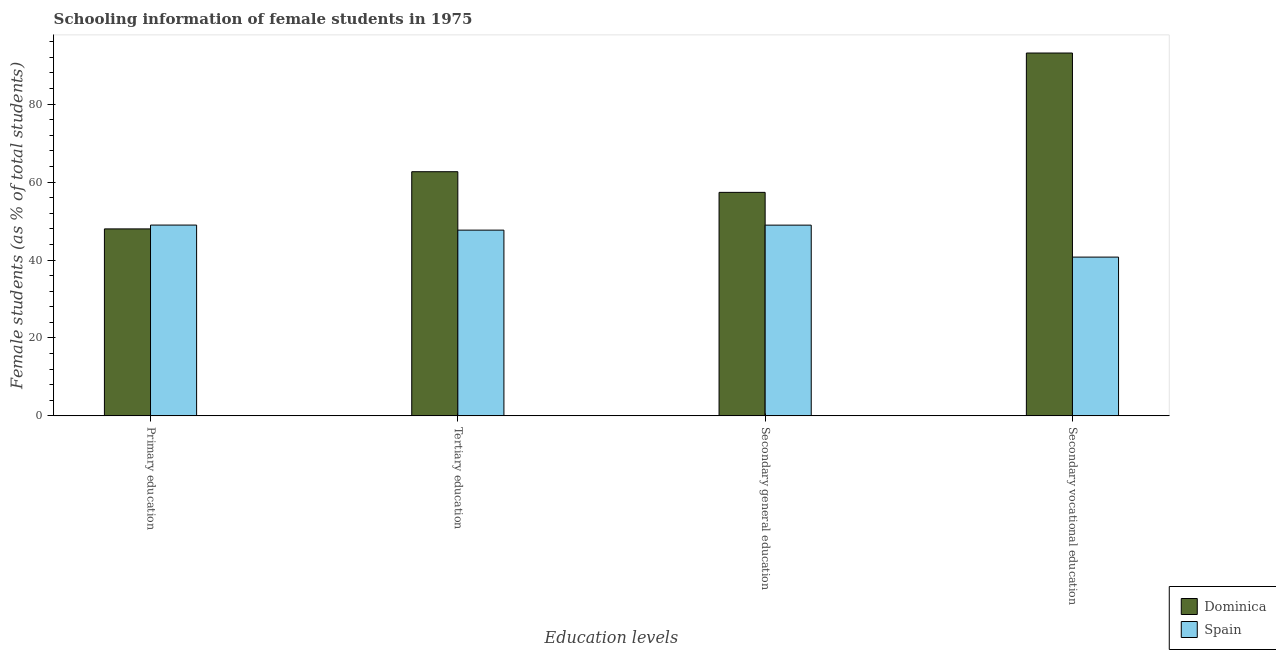Are the number of bars per tick equal to the number of legend labels?
Your answer should be compact. Yes. Are the number of bars on each tick of the X-axis equal?
Offer a terse response. Yes. What is the percentage of female students in primary education in Dominica?
Provide a short and direct response. 47.98. Across all countries, what is the maximum percentage of female students in secondary education?
Your response must be concise. 57.36. Across all countries, what is the minimum percentage of female students in primary education?
Keep it short and to the point. 47.98. In which country was the percentage of female students in tertiary education maximum?
Offer a terse response. Dominica. In which country was the percentage of female students in tertiary education minimum?
Provide a short and direct response. Spain. What is the total percentage of female students in primary education in the graph?
Offer a terse response. 96.95. What is the difference between the percentage of female students in tertiary education in Spain and that in Dominica?
Give a very brief answer. -14.99. What is the difference between the percentage of female students in secondary education in Dominica and the percentage of female students in tertiary education in Spain?
Your answer should be very brief. 9.69. What is the average percentage of female students in tertiary education per country?
Ensure brevity in your answer.  55.16. What is the difference between the percentage of female students in secondary vocational education and percentage of female students in secondary education in Dominica?
Provide a succinct answer. 35.76. In how many countries, is the percentage of female students in secondary vocational education greater than 52 %?
Your answer should be very brief. 1. What is the ratio of the percentage of female students in secondary education in Spain to that in Dominica?
Keep it short and to the point. 0.85. Is the percentage of female students in secondary education in Dominica less than that in Spain?
Your answer should be very brief. No. What is the difference between the highest and the second highest percentage of female students in primary education?
Provide a succinct answer. 0.98. What is the difference between the highest and the lowest percentage of female students in primary education?
Provide a short and direct response. 0.98. Is it the case that in every country, the sum of the percentage of female students in secondary education and percentage of female students in secondary vocational education is greater than the sum of percentage of female students in tertiary education and percentage of female students in primary education?
Offer a terse response. No. What does the 1st bar from the left in Secondary general education represents?
Your answer should be compact. Dominica. How many bars are there?
Your response must be concise. 8. How many countries are there in the graph?
Keep it short and to the point. 2. What is the difference between two consecutive major ticks on the Y-axis?
Make the answer very short. 20. Does the graph contain grids?
Offer a terse response. No. How many legend labels are there?
Your answer should be very brief. 2. What is the title of the graph?
Ensure brevity in your answer.  Schooling information of female students in 1975. What is the label or title of the X-axis?
Your response must be concise. Education levels. What is the label or title of the Y-axis?
Ensure brevity in your answer.  Female students (as % of total students). What is the Female students (as % of total students) of Dominica in Primary education?
Your response must be concise. 47.98. What is the Female students (as % of total students) in Spain in Primary education?
Your answer should be compact. 48.97. What is the Female students (as % of total students) of Dominica in Tertiary education?
Your answer should be compact. 62.66. What is the Female students (as % of total students) of Spain in Tertiary education?
Your response must be concise. 47.67. What is the Female students (as % of total students) of Dominica in Secondary general education?
Make the answer very short. 57.36. What is the Female students (as % of total students) of Spain in Secondary general education?
Offer a terse response. 48.95. What is the Female students (as % of total students) in Dominica in Secondary vocational education?
Your response must be concise. 93.12. What is the Female students (as % of total students) of Spain in Secondary vocational education?
Keep it short and to the point. 40.74. Across all Education levels, what is the maximum Female students (as % of total students) of Dominica?
Give a very brief answer. 93.12. Across all Education levels, what is the maximum Female students (as % of total students) in Spain?
Your answer should be compact. 48.97. Across all Education levels, what is the minimum Female students (as % of total students) of Dominica?
Keep it short and to the point. 47.98. Across all Education levels, what is the minimum Female students (as % of total students) of Spain?
Provide a succinct answer. 40.74. What is the total Female students (as % of total students) of Dominica in the graph?
Provide a short and direct response. 261.12. What is the total Female students (as % of total students) in Spain in the graph?
Your answer should be compact. 186.33. What is the difference between the Female students (as % of total students) in Dominica in Primary education and that in Tertiary education?
Make the answer very short. -14.68. What is the difference between the Female students (as % of total students) in Spain in Primary education and that in Tertiary education?
Provide a short and direct response. 1.3. What is the difference between the Female students (as % of total students) in Dominica in Primary education and that in Secondary general education?
Keep it short and to the point. -9.38. What is the difference between the Female students (as % of total students) of Spain in Primary education and that in Secondary general education?
Make the answer very short. 0.01. What is the difference between the Female students (as % of total students) in Dominica in Primary education and that in Secondary vocational education?
Offer a very short reply. -45.14. What is the difference between the Female students (as % of total students) in Spain in Primary education and that in Secondary vocational education?
Ensure brevity in your answer.  8.22. What is the difference between the Female students (as % of total students) of Dominica in Tertiary education and that in Secondary general education?
Make the answer very short. 5.3. What is the difference between the Female students (as % of total students) in Spain in Tertiary education and that in Secondary general education?
Your answer should be compact. -1.28. What is the difference between the Female students (as % of total students) of Dominica in Tertiary education and that in Secondary vocational education?
Provide a short and direct response. -30.46. What is the difference between the Female students (as % of total students) of Spain in Tertiary education and that in Secondary vocational education?
Your response must be concise. 6.92. What is the difference between the Female students (as % of total students) of Dominica in Secondary general education and that in Secondary vocational education?
Offer a terse response. -35.76. What is the difference between the Female students (as % of total students) in Spain in Secondary general education and that in Secondary vocational education?
Your answer should be compact. 8.21. What is the difference between the Female students (as % of total students) in Dominica in Primary education and the Female students (as % of total students) in Spain in Tertiary education?
Provide a short and direct response. 0.32. What is the difference between the Female students (as % of total students) of Dominica in Primary education and the Female students (as % of total students) of Spain in Secondary general education?
Make the answer very short. -0.97. What is the difference between the Female students (as % of total students) of Dominica in Primary education and the Female students (as % of total students) of Spain in Secondary vocational education?
Keep it short and to the point. 7.24. What is the difference between the Female students (as % of total students) in Dominica in Tertiary education and the Female students (as % of total students) in Spain in Secondary general education?
Offer a terse response. 13.71. What is the difference between the Female students (as % of total students) in Dominica in Tertiary education and the Female students (as % of total students) in Spain in Secondary vocational education?
Provide a succinct answer. 21.91. What is the difference between the Female students (as % of total students) of Dominica in Secondary general education and the Female students (as % of total students) of Spain in Secondary vocational education?
Give a very brief answer. 16.62. What is the average Female students (as % of total students) of Dominica per Education levels?
Ensure brevity in your answer.  65.28. What is the average Female students (as % of total students) of Spain per Education levels?
Keep it short and to the point. 46.58. What is the difference between the Female students (as % of total students) in Dominica and Female students (as % of total students) in Spain in Primary education?
Offer a terse response. -0.98. What is the difference between the Female students (as % of total students) in Dominica and Female students (as % of total students) in Spain in Tertiary education?
Keep it short and to the point. 14.99. What is the difference between the Female students (as % of total students) of Dominica and Female students (as % of total students) of Spain in Secondary general education?
Your response must be concise. 8.41. What is the difference between the Female students (as % of total students) of Dominica and Female students (as % of total students) of Spain in Secondary vocational education?
Your answer should be very brief. 52.38. What is the ratio of the Female students (as % of total students) of Dominica in Primary education to that in Tertiary education?
Your answer should be compact. 0.77. What is the ratio of the Female students (as % of total students) in Spain in Primary education to that in Tertiary education?
Provide a succinct answer. 1.03. What is the ratio of the Female students (as % of total students) in Dominica in Primary education to that in Secondary general education?
Offer a terse response. 0.84. What is the ratio of the Female students (as % of total students) in Dominica in Primary education to that in Secondary vocational education?
Make the answer very short. 0.52. What is the ratio of the Female students (as % of total students) in Spain in Primary education to that in Secondary vocational education?
Give a very brief answer. 1.2. What is the ratio of the Female students (as % of total students) of Dominica in Tertiary education to that in Secondary general education?
Your answer should be very brief. 1.09. What is the ratio of the Female students (as % of total students) in Spain in Tertiary education to that in Secondary general education?
Your answer should be very brief. 0.97. What is the ratio of the Female students (as % of total students) in Dominica in Tertiary education to that in Secondary vocational education?
Your answer should be very brief. 0.67. What is the ratio of the Female students (as % of total students) of Spain in Tertiary education to that in Secondary vocational education?
Provide a short and direct response. 1.17. What is the ratio of the Female students (as % of total students) in Dominica in Secondary general education to that in Secondary vocational education?
Provide a succinct answer. 0.62. What is the ratio of the Female students (as % of total students) in Spain in Secondary general education to that in Secondary vocational education?
Make the answer very short. 1.2. What is the difference between the highest and the second highest Female students (as % of total students) in Dominica?
Keep it short and to the point. 30.46. What is the difference between the highest and the second highest Female students (as % of total students) of Spain?
Provide a short and direct response. 0.01. What is the difference between the highest and the lowest Female students (as % of total students) in Dominica?
Make the answer very short. 45.14. What is the difference between the highest and the lowest Female students (as % of total students) in Spain?
Your answer should be compact. 8.22. 